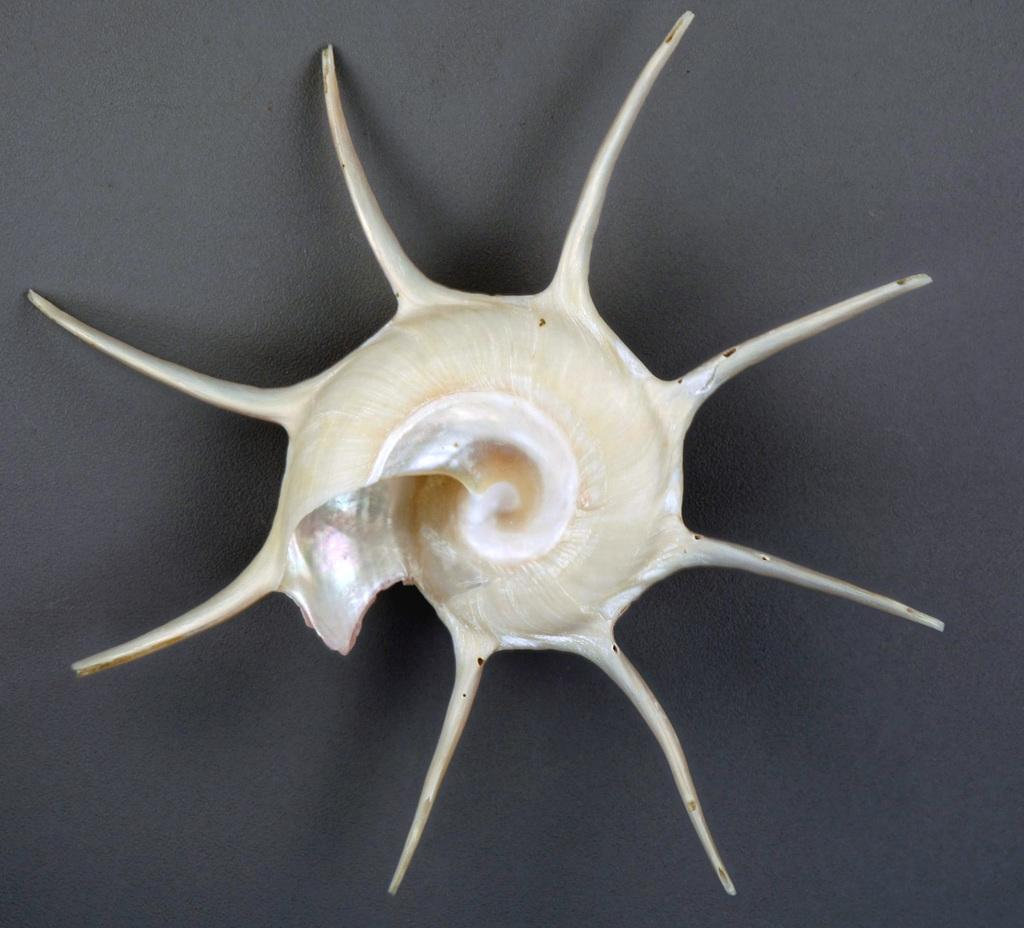What is the main subject of the image? The main subject of the image is a snail's cell. What is the color of the snail's cell? The snail's cell is white in color. What is the color of the background in the image? The background of the image is white. What type of spoon can be seen interacting with the snail's cell in the image? There is no spoon present in the image, and therefore no such interaction can be observed. 